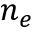<formula> <loc_0><loc_0><loc_500><loc_500>n _ { e }</formula> 